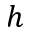Convert formula to latex. <formula><loc_0><loc_0><loc_500><loc_500>h</formula> 